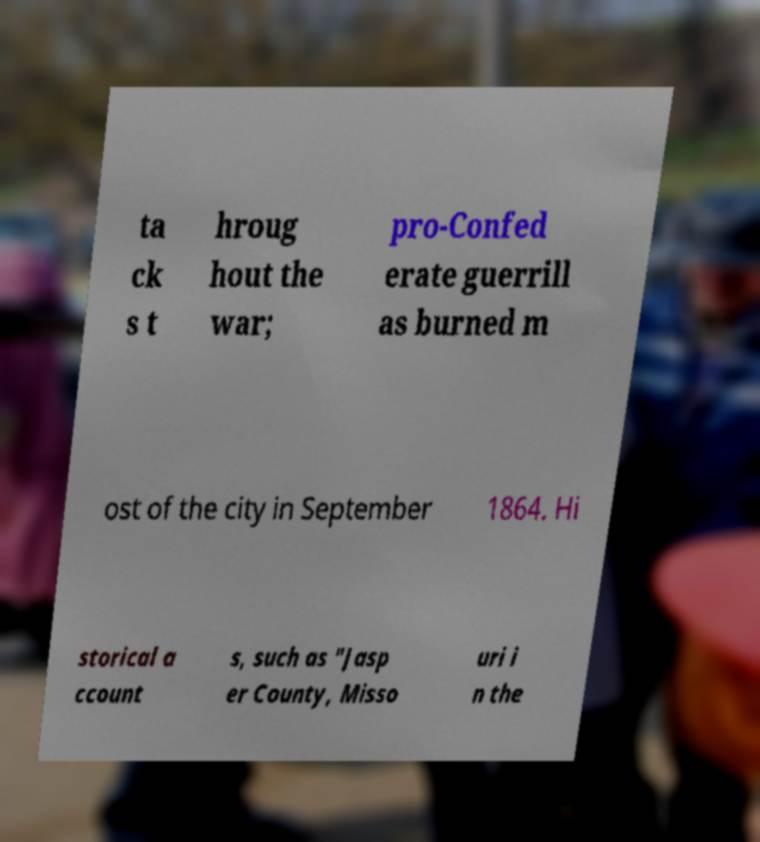Please read and relay the text visible in this image. What does it say? ta ck s t hroug hout the war; pro-Confed erate guerrill as burned m ost of the city in September 1864. Hi storical a ccount s, such as "Jasp er County, Misso uri i n the 